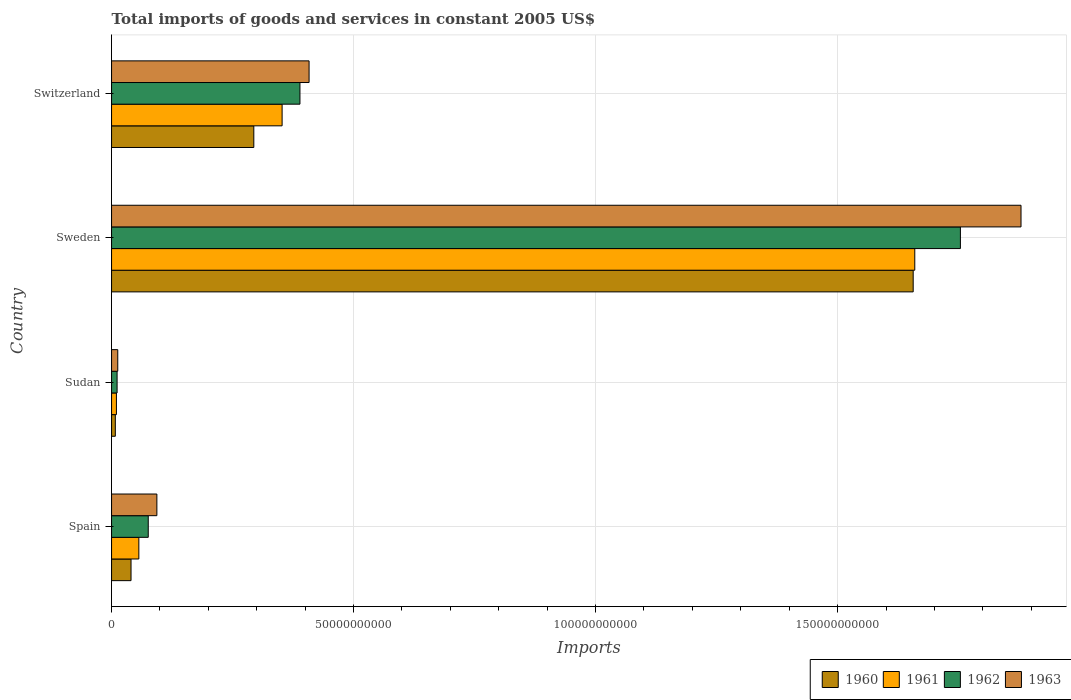How many groups of bars are there?
Your answer should be very brief. 4. Are the number of bars per tick equal to the number of legend labels?
Give a very brief answer. Yes. Are the number of bars on each tick of the Y-axis equal?
Provide a short and direct response. Yes. How many bars are there on the 2nd tick from the top?
Provide a short and direct response. 4. How many bars are there on the 2nd tick from the bottom?
Your answer should be compact. 4. What is the label of the 2nd group of bars from the top?
Ensure brevity in your answer.  Sweden. In how many cases, is the number of bars for a given country not equal to the number of legend labels?
Keep it short and to the point. 0. What is the total imports of goods and services in 1961 in Switzerland?
Give a very brief answer. 3.52e+1. Across all countries, what is the maximum total imports of goods and services in 1963?
Provide a short and direct response. 1.88e+11. Across all countries, what is the minimum total imports of goods and services in 1961?
Make the answer very short. 1.00e+09. In which country was the total imports of goods and services in 1961 minimum?
Make the answer very short. Sudan. What is the total total imports of goods and services in 1962 in the graph?
Provide a succinct answer. 2.23e+11. What is the difference between the total imports of goods and services in 1960 in Sudan and that in Sweden?
Keep it short and to the point. -1.65e+11. What is the difference between the total imports of goods and services in 1960 in Sudan and the total imports of goods and services in 1961 in Sweden?
Your answer should be very brief. -1.65e+11. What is the average total imports of goods and services in 1960 per country?
Your answer should be very brief. 5.00e+1. What is the difference between the total imports of goods and services in 1961 and total imports of goods and services in 1960 in Switzerland?
Offer a very short reply. 5.85e+09. What is the ratio of the total imports of goods and services in 1963 in Sudan to that in Sweden?
Provide a short and direct response. 0.01. Is the total imports of goods and services in 1960 in Sweden less than that in Switzerland?
Your answer should be very brief. No. Is the difference between the total imports of goods and services in 1961 in Spain and Sudan greater than the difference between the total imports of goods and services in 1960 in Spain and Sudan?
Your answer should be compact. Yes. What is the difference between the highest and the second highest total imports of goods and services in 1963?
Provide a short and direct response. 1.47e+11. What is the difference between the highest and the lowest total imports of goods and services in 1962?
Offer a terse response. 1.74e+11. Is it the case that in every country, the sum of the total imports of goods and services in 1962 and total imports of goods and services in 1963 is greater than the sum of total imports of goods and services in 1961 and total imports of goods and services in 1960?
Keep it short and to the point. No. What does the 1st bar from the top in Sweden represents?
Make the answer very short. 1963. Are all the bars in the graph horizontal?
Your response must be concise. Yes. Are the values on the major ticks of X-axis written in scientific E-notation?
Provide a short and direct response. No. Where does the legend appear in the graph?
Your response must be concise. Bottom right. What is the title of the graph?
Ensure brevity in your answer.  Total imports of goods and services in constant 2005 US$. Does "2013" appear as one of the legend labels in the graph?
Your answer should be very brief. No. What is the label or title of the X-axis?
Provide a short and direct response. Imports. What is the label or title of the Y-axis?
Your answer should be compact. Country. What is the Imports of 1960 in Spain?
Your answer should be very brief. 4.02e+09. What is the Imports in 1961 in Spain?
Ensure brevity in your answer.  5.64e+09. What is the Imports in 1962 in Spain?
Give a very brief answer. 7.58e+09. What is the Imports of 1963 in Spain?
Your response must be concise. 9.36e+09. What is the Imports in 1960 in Sudan?
Offer a terse response. 7.79e+08. What is the Imports of 1961 in Sudan?
Your answer should be compact. 1.00e+09. What is the Imports of 1962 in Sudan?
Your response must be concise. 1.14e+09. What is the Imports of 1963 in Sudan?
Offer a terse response. 1.28e+09. What is the Imports of 1960 in Sweden?
Offer a very short reply. 1.66e+11. What is the Imports in 1961 in Sweden?
Give a very brief answer. 1.66e+11. What is the Imports of 1962 in Sweden?
Your answer should be compact. 1.75e+11. What is the Imports of 1963 in Sweden?
Your answer should be very brief. 1.88e+11. What is the Imports in 1960 in Switzerland?
Your response must be concise. 2.94e+1. What is the Imports in 1961 in Switzerland?
Offer a terse response. 3.52e+1. What is the Imports in 1962 in Switzerland?
Your answer should be compact. 3.89e+1. What is the Imports of 1963 in Switzerland?
Your answer should be compact. 4.08e+1. Across all countries, what is the maximum Imports of 1960?
Ensure brevity in your answer.  1.66e+11. Across all countries, what is the maximum Imports in 1961?
Offer a terse response. 1.66e+11. Across all countries, what is the maximum Imports of 1962?
Your answer should be very brief. 1.75e+11. Across all countries, what is the maximum Imports in 1963?
Ensure brevity in your answer.  1.88e+11. Across all countries, what is the minimum Imports of 1960?
Offer a terse response. 7.79e+08. Across all countries, what is the minimum Imports of 1961?
Give a very brief answer. 1.00e+09. Across all countries, what is the minimum Imports in 1962?
Provide a succinct answer. 1.14e+09. Across all countries, what is the minimum Imports in 1963?
Your response must be concise. 1.28e+09. What is the total Imports of 1960 in the graph?
Your response must be concise. 2.00e+11. What is the total Imports of 1961 in the graph?
Your response must be concise. 2.08e+11. What is the total Imports in 1962 in the graph?
Your answer should be very brief. 2.23e+11. What is the total Imports of 1963 in the graph?
Your response must be concise. 2.39e+11. What is the difference between the Imports in 1960 in Spain and that in Sudan?
Your response must be concise. 3.24e+09. What is the difference between the Imports in 1961 in Spain and that in Sudan?
Offer a very short reply. 4.63e+09. What is the difference between the Imports of 1962 in Spain and that in Sudan?
Provide a succinct answer. 6.44e+09. What is the difference between the Imports of 1963 in Spain and that in Sudan?
Offer a very short reply. 8.08e+09. What is the difference between the Imports of 1960 in Spain and that in Sweden?
Offer a very short reply. -1.62e+11. What is the difference between the Imports in 1961 in Spain and that in Sweden?
Provide a short and direct response. -1.60e+11. What is the difference between the Imports of 1962 in Spain and that in Sweden?
Your answer should be compact. -1.68e+11. What is the difference between the Imports in 1963 in Spain and that in Sweden?
Provide a succinct answer. -1.79e+11. What is the difference between the Imports in 1960 in Spain and that in Switzerland?
Make the answer very short. -2.54e+1. What is the difference between the Imports in 1961 in Spain and that in Switzerland?
Your answer should be compact. -2.96e+1. What is the difference between the Imports of 1962 in Spain and that in Switzerland?
Offer a very short reply. -3.13e+1. What is the difference between the Imports of 1963 in Spain and that in Switzerland?
Your answer should be compact. -3.14e+1. What is the difference between the Imports of 1960 in Sudan and that in Sweden?
Provide a short and direct response. -1.65e+11. What is the difference between the Imports in 1961 in Sudan and that in Sweden?
Ensure brevity in your answer.  -1.65e+11. What is the difference between the Imports in 1962 in Sudan and that in Sweden?
Provide a succinct answer. -1.74e+11. What is the difference between the Imports of 1963 in Sudan and that in Sweden?
Your answer should be compact. -1.87e+11. What is the difference between the Imports of 1960 in Sudan and that in Switzerland?
Ensure brevity in your answer.  -2.86e+1. What is the difference between the Imports of 1961 in Sudan and that in Switzerland?
Keep it short and to the point. -3.42e+1. What is the difference between the Imports in 1962 in Sudan and that in Switzerland?
Your answer should be very brief. -3.78e+1. What is the difference between the Imports of 1963 in Sudan and that in Switzerland?
Make the answer very short. -3.95e+1. What is the difference between the Imports of 1960 in Sweden and that in Switzerland?
Give a very brief answer. 1.36e+11. What is the difference between the Imports in 1961 in Sweden and that in Switzerland?
Make the answer very short. 1.31e+11. What is the difference between the Imports of 1962 in Sweden and that in Switzerland?
Give a very brief answer. 1.36e+11. What is the difference between the Imports in 1963 in Sweden and that in Switzerland?
Ensure brevity in your answer.  1.47e+11. What is the difference between the Imports of 1960 in Spain and the Imports of 1961 in Sudan?
Keep it short and to the point. 3.02e+09. What is the difference between the Imports of 1960 in Spain and the Imports of 1962 in Sudan?
Provide a succinct answer. 2.88e+09. What is the difference between the Imports in 1960 in Spain and the Imports in 1963 in Sudan?
Your response must be concise. 2.74e+09. What is the difference between the Imports in 1961 in Spain and the Imports in 1962 in Sudan?
Your response must be concise. 4.49e+09. What is the difference between the Imports in 1961 in Spain and the Imports in 1963 in Sudan?
Provide a short and direct response. 4.35e+09. What is the difference between the Imports in 1962 in Spain and the Imports in 1963 in Sudan?
Your answer should be very brief. 6.30e+09. What is the difference between the Imports of 1960 in Spain and the Imports of 1961 in Sweden?
Provide a short and direct response. -1.62e+11. What is the difference between the Imports of 1960 in Spain and the Imports of 1962 in Sweden?
Offer a terse response. -1.71e+11. What is the difference between the Imports of 1960 in Spain and the Imports of 1963 in Sweden?
Your answer should be compact. -1.84e+11. What is the difference between the Imports in 1961 in Spain and the Imports in 1962 in Sweden?
Make the answer very short. -1.70e+11. What is the difference between the Imports in 1961 in Spain and the Imports in 1963 in Sweden?
Provide a succinct answer. -1.82e+11. What is the difference between the Imports in 1962 in Spain and the Imports in 1963 in Sweden?
Keep it short and to the point. -1.80e+11. What is the difference between the Imports in 1960 in Spain and the Imports in 1961 in Switzerland?
Offer a very short reply. -3.12e+1. What is the difference between the Imports in 1960 in Spain and the Imports in 1962 in Switzerland?
Make the answer very short. -3.49e+1. What is the difference between the Imports of 1960 in Spain and the Imports of 1963 in Switzerland?
Make the answer very short. -3.68e+1. What is the difference between the Imports of 1961 in Spain and the Imports of 1962 in Switzerland?
Offer a terse response. -3.33e+1. What is the difference between the Imports of 1961 in Spain and the Imports of 1963 in Switzerland?
Your answer should be very brief. -3.52e+1. What is the difference between the Imports of 1962 in Spain and the Imports of 1963 in Switzerland?
Your answer should be compact. -3.32e+1. What is the difference between the Imports in 1960 in Sudan and the Imports in 1961 in Sweden?
Keep it short and to the point. -1.65e+11. What is the difference between the Imports in 1960 in Sudan and the Imports in 1962 in Sweden?
Offer a terse response. -1.75e+11. What is the difference between the Imports of 1960 in Sudan and the Imports of 1963 in Sweden?
Provide a succinct answer. -1.87e+11. What is the difference between the Imports in 1961 in Sudan and the Imports in 1962 in Sweden?
Ensure brevity in your answer.  -1.74e+11. What is the difference between the Imports of 1961 in Sudan and the Imports of 1963 in Sweden?
Your response must be concise. -1.87e+11. What is the difference between the Imports of 1962 in Sudan and the Imports of 1963 in Sweden?
Make the answer very short. -1.87e+11. What is the difference between the Imports of 1960 in Sudan and the Imports of 1961 in Switzerland?
Your answer should be compact. -3.45e+1. What is the difference between the Imports of 1960 in Sudan and the Imports of 1962 in Switzerland?
Offer a very short reply. -3.81e+1. What is the difference between the Imports in 1960 in Sudan and the Imports in 1963 in Switzerland?
Give a very brief answer. -4.00e+1. What is the difference between the Imports in 1961 in Sudan and the Imports in 1962 in Switzerland?
Your response must be concise. -3.79e+1. What is the difference between the Imports of 1961 in Sudan and the Imports of 1963 in Switzerland?
Your answer should be very brief. -3.98e+1. What is the difference between the Imports of 1962 in Sudan and the Imports of 1963 in Switzerland?
Your answer should be compact. -3.97e+1. What is the difference between the Imports in 1960 in Sweden and the Imports in 1961 in Switzerland?
Your response must be concise. 1.30e+11. What is the difference between the Imports in 1960 in Sweden and the Imports in 1962 in Switzerland?
Offer a terse response. 1.27e+11. What is the difference between the Imports in 1960 in Sweden and the Imports in 1963 in Switzerland?
Give a very brief answer. 1.25e+11. What is the difference between the Imports in 1961 in Sweden and the Imports in 1962 in Switzerland?
Offer a very short reply. 1.27e+11. What is the difference between the Imports in 1961 in Sweden and the Imports in 1963 in Switzerland?
Your answer should be compact. 1.25e+11. What is the difference between the Imports of 1962 in Sweden and the Imports of 1963 in Switzerland?
Make the answer very short. 1.35e+11. What is the average Imports of 1960 per country?
Give a very brief answer. 5.00e+1. What is the average Imports in 1961 per country?
Ensure brevity in your answer.  5.20e+1. What is the average Imports in 1962 per country?
Keep it short and to the point. 5.58e+1. What is the average Imports of 1963 per country?
Provide a short and direct response. 5.98e+1. What is the difference between the Imports in 1960 and Imports in 1961 in Spain?
Provide a short and direct response. -1.61e+09. What is the difference between the Imports in 1960 and Imports in 1962 in Spain?
Your answer should be compact. -3.56e+09. What is the difference between the Imports in 1960 and Imports in 1963 in Spain?
Ensure brevity in your answer.  -5.34e+09. What is the difference between the Imports of 1961 and Imports of 1962 in Spain?
Provide a short and direct response. -1.94e+09. What is the difference between the Imports of 1961 and Imports of 1963 in Spain?
Give a very brief answer. -3.72e+09. What is the difference between the Imports of 1962 and Imports of 1963 in Spain?
Provide a succinct answer. -1.78e+09. What is the difference between the Imports of 1960 and Imports of 1961 in Sudan?
Offer a very short reply. -2.25e+08. What is the difference between the Imports in 1960 and Imports in 1962 in Sudan?
Make the answer very short. -3.65e+08. What is the difference between the Imports of 1960 and Imports of 1963 in Sudan?
Your answer should be compact. -5.04e+08. What is the difference between the Imports of 1961 and Imports of 1962 in Sudan?
Keep it short and to the point. -1.39e+08. What is the difference between the Imports of 1961 and Imports of 1963 in Sudan?
Your response must be concise. -2.79e+08. What is the difference between the Imports in 1962 and Imports in 1963 in Sudan?
Your response must be concise. -1.39e+08. What is the difference between the Imports in 1960 and Imports in 1961 in Sweden?
Ensure brevity in your answer.  -3.29e+08. What is the difference between the Imports of 1960 and Imports of 1962 in Sweden?
Your answer should be very brief. -9.75e+09. What is the difference between the Imports of 1960 and Imports of 1963 in Sweden?
Provide a succinct answer. -2.23e+1. What is the difference between the Imports in 1961 and Imports in 1962 in Sweden?
Offer a very short reply. -9.42e+09. What is the difference between the Imports of 1961 and Imports of 1963 in Sweden?
Your answer should be very brief. -2.19e+1. What is the difference between the Imports in 1962 and Imports in 1963 in Sweden?
Ensure brevity in your answer.  -1.25e+1. What is the difference between the Imports in 1960 and Imports in 1961 in Switzerland?
Provide a short and direct response. -5.85e+09. What is the difference between the Imports of 1960 and Imports of 1962 in Switzerland?
Ensure brevity in your answer.  -9.53e+09. What is the difference between the Imports in 1960 and Imports in 1963 in Switzerland?
Your response must be concise. -1.14e+1. What is the difference between the Imports of 1961 and Imports of 1962 in Switzerland?
Provide a short and direct response. -3.69e+09. What is the difference between the Imports in 1961 and Imports in 1963 in Switzerland?
Offer a very short reply. -5.57e+09. What is the difference between the Imports in 1962 and Imports in 1963 in Switzerland?
Keep it short and to the point. -1.88e+09. What is the ratio of the Imports of 1960 in Spain to that in Sudan?
Your response must be concise. 5.16. What is the ratio of the Imports in 1961 in Spain to that in Sudan?
Your answer should be very brief. 5.61. What is the ratio of the Imports of 1962 in Spain to that in Sudan?
Keep it short and to the point. 6.63. What is the ratio of the Imports of 1963 in Spain to that in Sudan?
Provide a short and direct response. 7.3. What is the ratio of the Imports in 1960 in Spain to that in Sweden?
Make the answer very short. 0.02. What is the ratio of the Imports in 1961 in Spain to that in Sweden?
Your answer should be compact. 0.03. What is the ratio of the Imports in 1962 in Spain to that in Sweden?
Ensure brevity in your answer.  0.04. What is the ratio of the Imports of 1963 in Spain to that in Sweden?
Offer a terse response. 0.05. What is the ratio of the Imports of 1960 in Spain to that in Switzerland?
Ensure brevity in your answer.  0.14. What is the ratio of the Imports of 1961 in Spain to that in Switzerland?
Ensure brevity in your answer.  0.16. What is the ratio of the Imports of 1962 in Spain to that in Switzerland?
Keep it short and to the point. 0.19. What is the ratio of the Imports of 1963 in Spain to that in Switzerland?
Offer a terse response. 0.23. What is the ratio of the Imports in 1960 in Sudan to that in Sweden?
Offer a terse response. 0. What is the ratio of the Imports in 1961 in Sudan to that in Sweden?
Give a very brief answer. 0.01. What is the ratio of the Imports in 1962 in Sudan to that in Sweden?
Offer a very short reply. 0.01. What is the ratio of the Imports of 1963 in Sudan to that in Sweden?
Give a very brief answer. 0.01. What is the ratio of the Imports of 1960 in Sudan to that in Switzerland?
Your answer should be very brief. 0.03. What is the ratio of the Imports in 1961 in Sudan to that in Switzerland?
Your response must be concise. 0.03. What is the ratio of the Imports of 1962 in Sudan to that in Switzerland?
Give a very brief answer. 0.03. What is the ratio of the Imports of 1963 in Sudan to that in Switzerland?
Give a very brief answer. 0.03. What is the ratio of the Imports of 1960 in Sweden to that in Switzerland?
Provide a short and direct response. 5.64. What is the ratio of the Imports of 1961 in Sweden to that in Switzerland?
Offer a very short reply. 4.71. What is the ratio of the Imports of 1962 in Sweden to that in Switzerland?
Offer a very short reply. 4.51. What is the ratio of the Imports in 1963 in Sweden to that in Switzerland?
Provide a short and direct response. 4.6. What is the difference between the highest and the second highest Imports in 1960?
Provide a succinct answer. 1.36e+11. What is the difference between the highest and the second highest Imports in 1961?
Offer a terse response. 1.31e+11. What is the difference between the highest and the second highest Imports in 1962?
Make the answer very short. 1.36e+11. What is the difference between the highest and the second highest Imports of 1963?
Provide a succinct answer. 1.47e+11. What is the difference between the highest and the lowest Imports in 1960?
Your response must be concise. 1.65e+11. What is the difference between the highest and the lowest Imports in 1961?
Keep it short and to the point. 1.65e+11. What is the difference between the highest and the lowest Imports of 1962?
Your answer should be very brief. 1.74e+11. What is the difference between the highest and the lowest Imports of 1963?
Make the answer very short. 1.87e+11. 